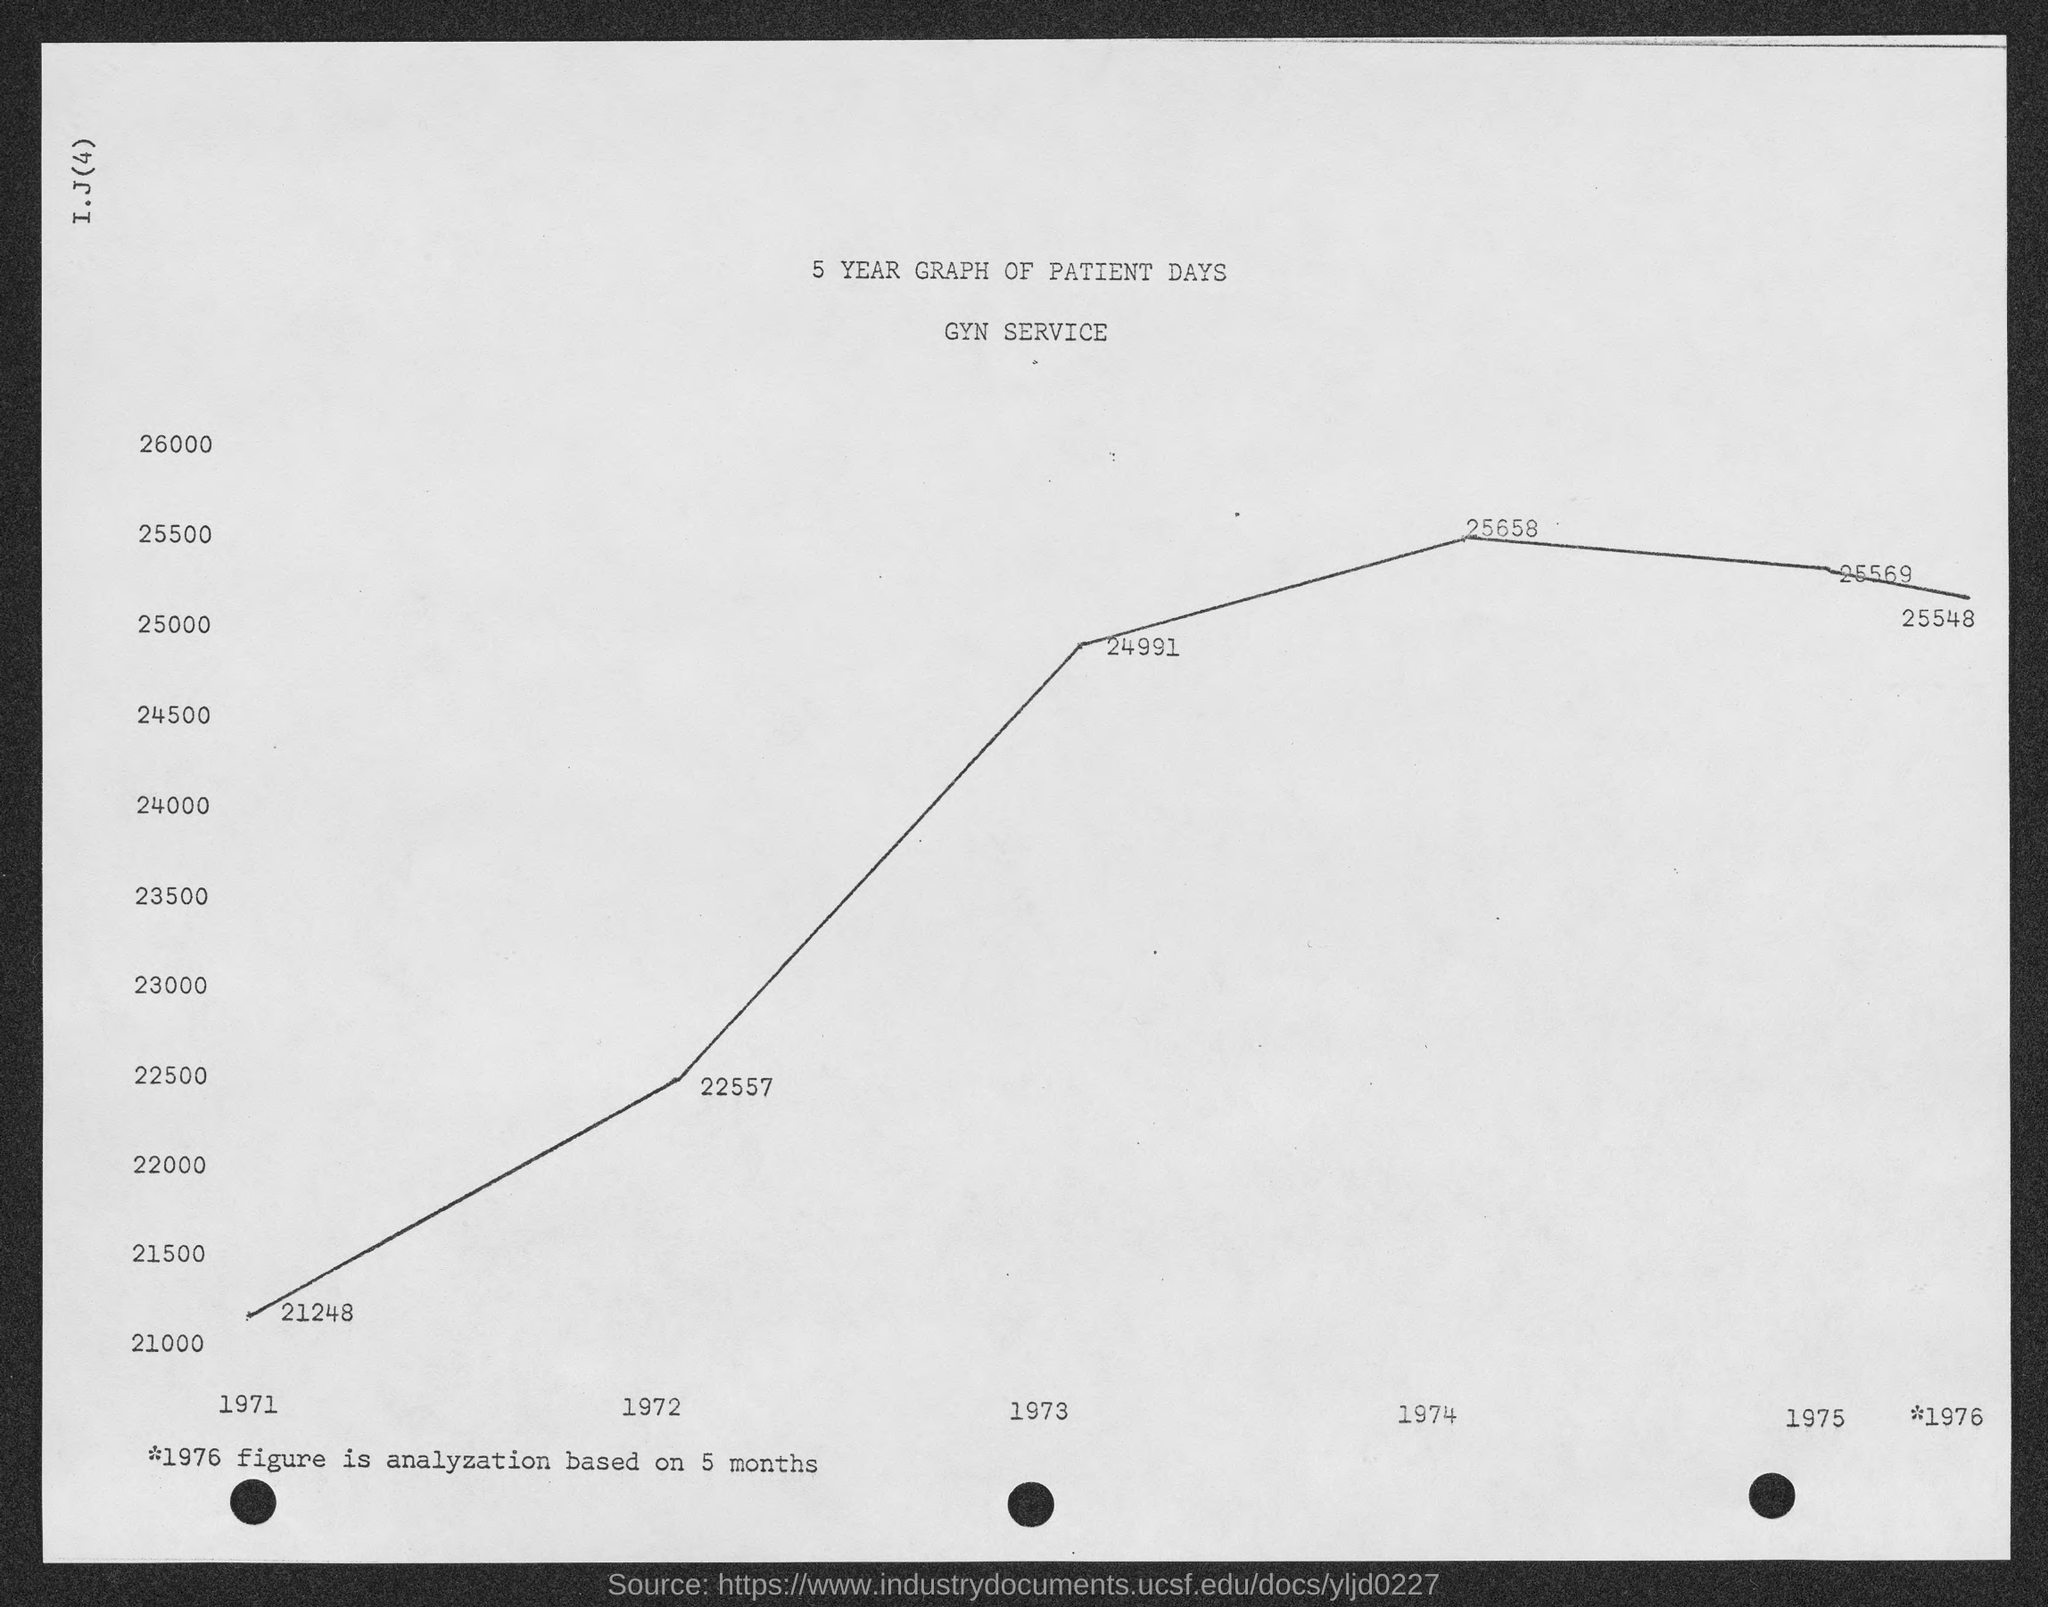What is the amount of patient days in the year 1971 ?
Your answer should be compact. 21248. What is the amount of patient days in the year 1972 ?
Provide a succinct answer. 22557. What is the amount of patient days in the year 1973 ?
Provide a succinct answer. 24991. What is the amount of patient days in the year 1974 ?
Make the answer very short. 25658. What is the amount of patient days in the year 1975 ?
Your response must be concise. 25569. 